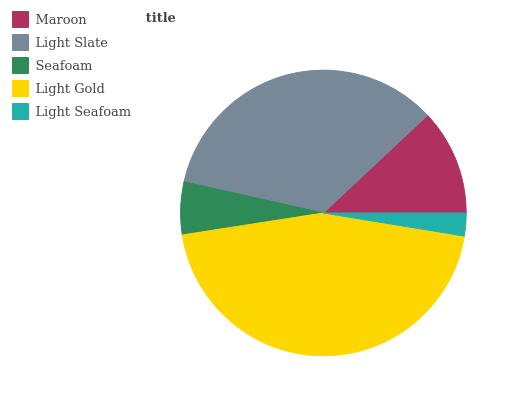Is Light Seafoam the minimum?
Answer yes or no. Yes. Is Light Gold the maximum?
Answer yes or no. Yes. Is Light Slate the minimum?
Answer yes or no. No. Is Light Slate the maximum?
Answer yes or no. No. Is Light Slate greater than Maroon?
Answer yes or no. Yes. Is Maroon less than Light Slate?
Answer yes or no. Yes. Is Maroon greater than Light Slate?
Answer yes or no. No. Is Light Slate less than Maroon?
Answer yes or no. No. Is Maroon the high median?
Answer yes or no. Yes. Is Maroon the low median?
Answer yes or no. Yes. Is Light Gold the high median?
Answer yes or no. No. Is Light Seafoam the low median?
Answer yes or no. No. 